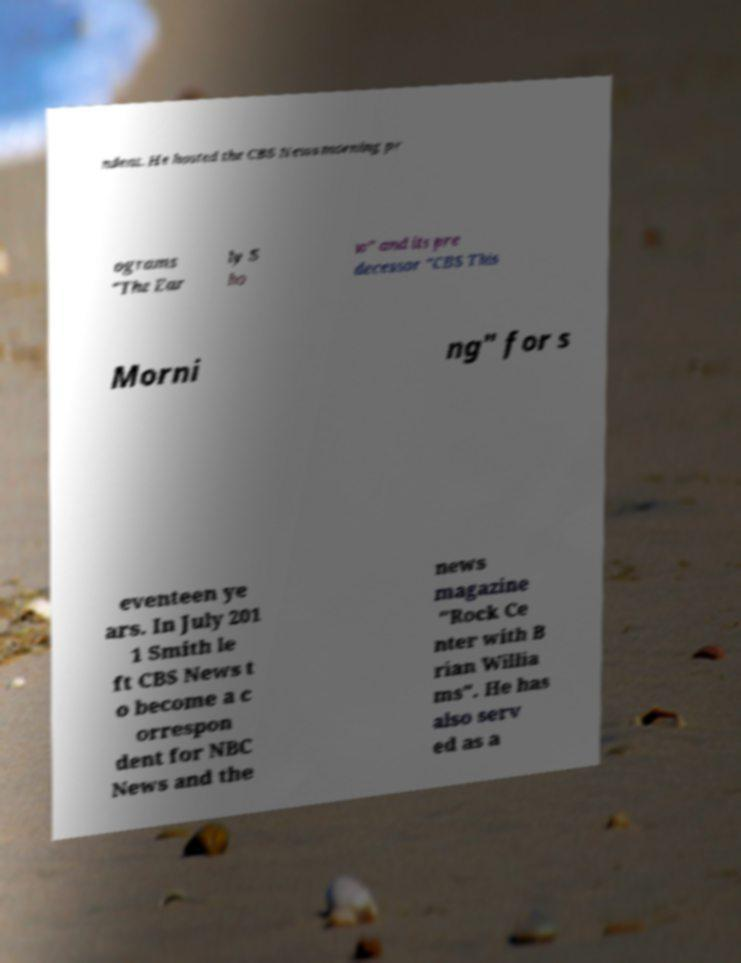Please identify and transcribe the text found in this image. ndent. He hosted the CBS News morning pr ograms "The Ear ly S ho w" and its pre decessor "CBS This Morni ng" for s eventeen ye ars. In July 201 1 Smith le ft CBS News t o become a c orrespon dent for NBC News and the news magazine "Rock Ce nter with B rian Willia ms". He has also serv ed as a 